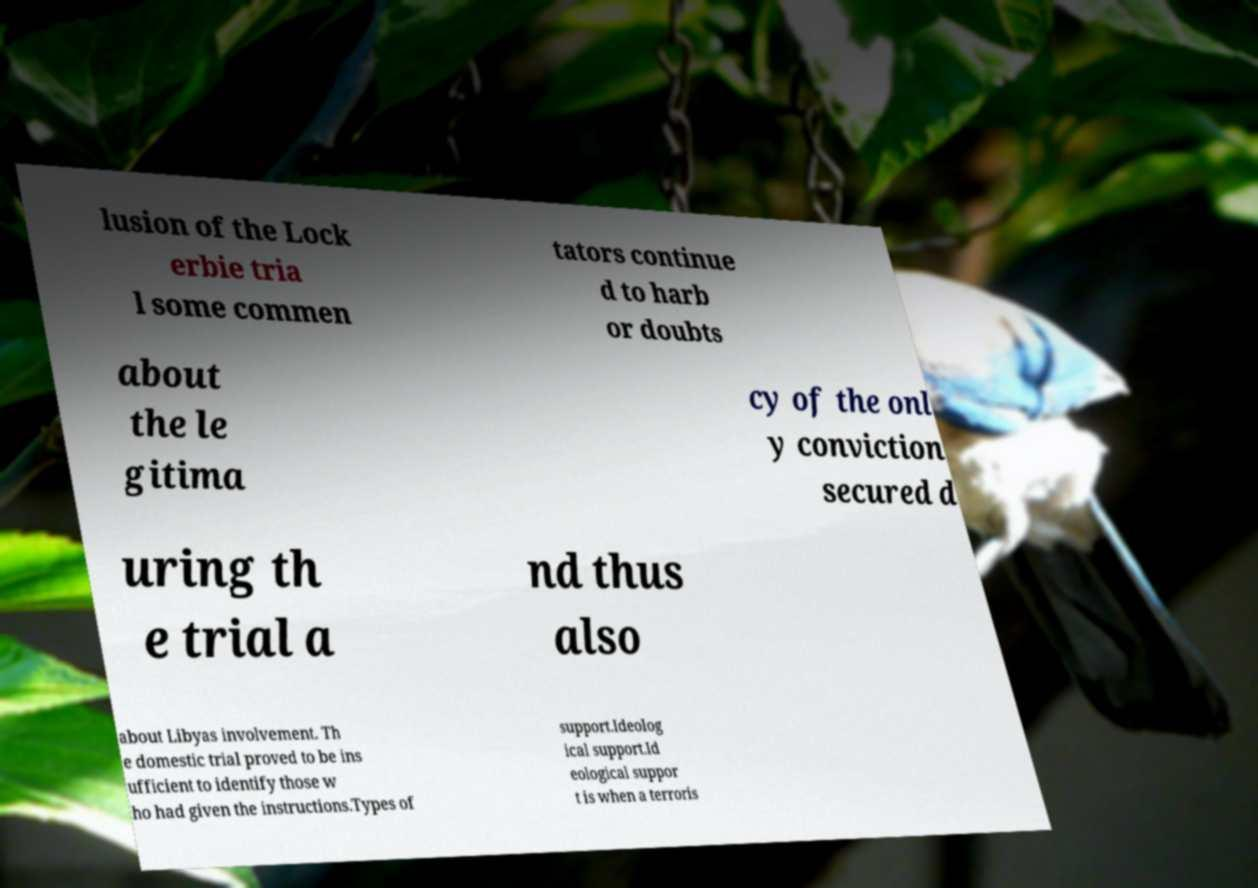Can you read and provide the text displayed in the image?This photo seems to have some interesting text. Can you extract and type it out for me? lusion of the Lock erbie tria l some commen tators continue d to harb or doubts about the le gitima cy of the onl y conviction secured d uring th e trial a nd thus also about Libyas involvement. Th e domestic trial proved to be ins ufficient to identify those w ho had given the instructions.Types of support.Ideolog ical support.Id eological suppor t is when a terroris 